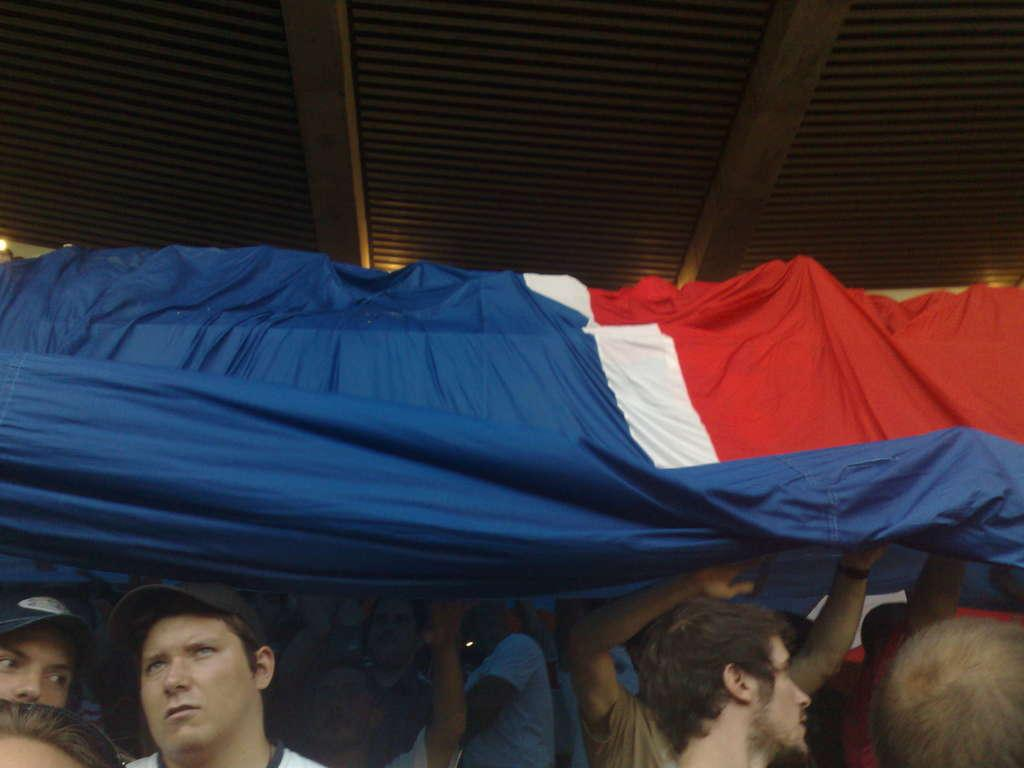What is happening in the foreground of the image? There are people in the foreground of the image. What are the people holding in the image? The people are holding a flag. What can be seen at the top of the image? There is a ceiling visible at the top of the image. How many sisters are depicted in the image? There is no mention of sisters in the image, so it cannot be determined from the facts provided. 